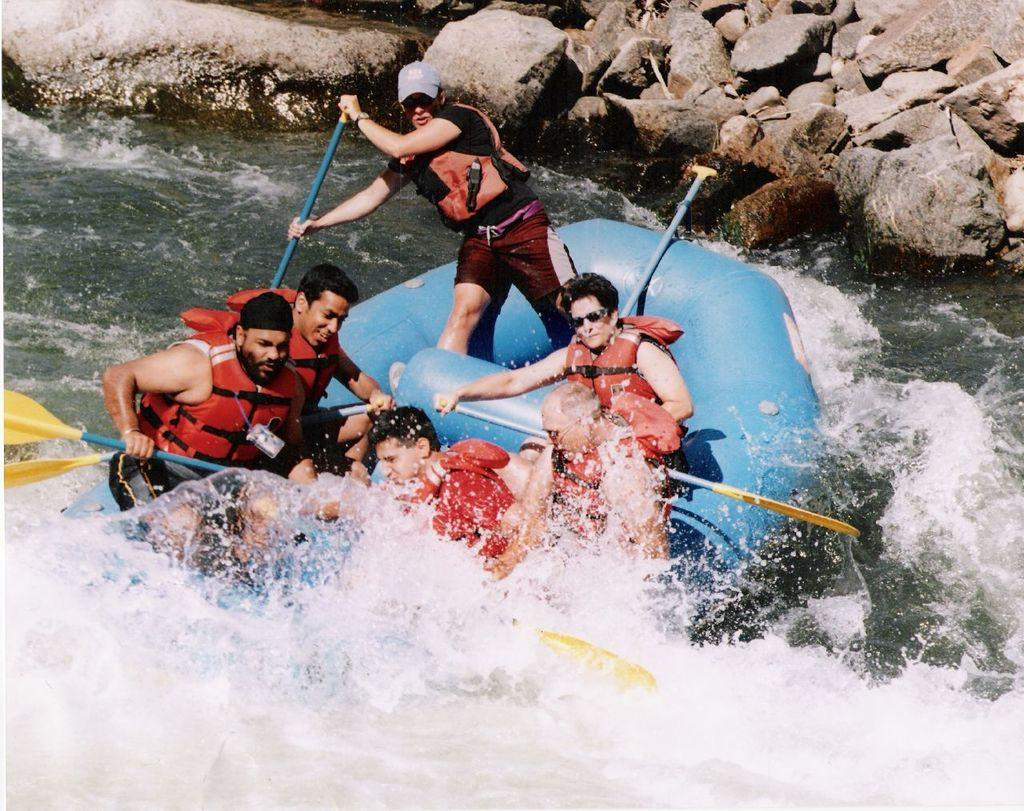Who or what can be seen in the image? There are persons in the image. What are the persons doing in the image? The persons are boating on the water. What can be seen in the background of the image? There are rocks in the background of the image. What type of advertisement can be seen on the water in the image? There is no advertisement present in the image; it features persons boating on the water with rocks in the background. 